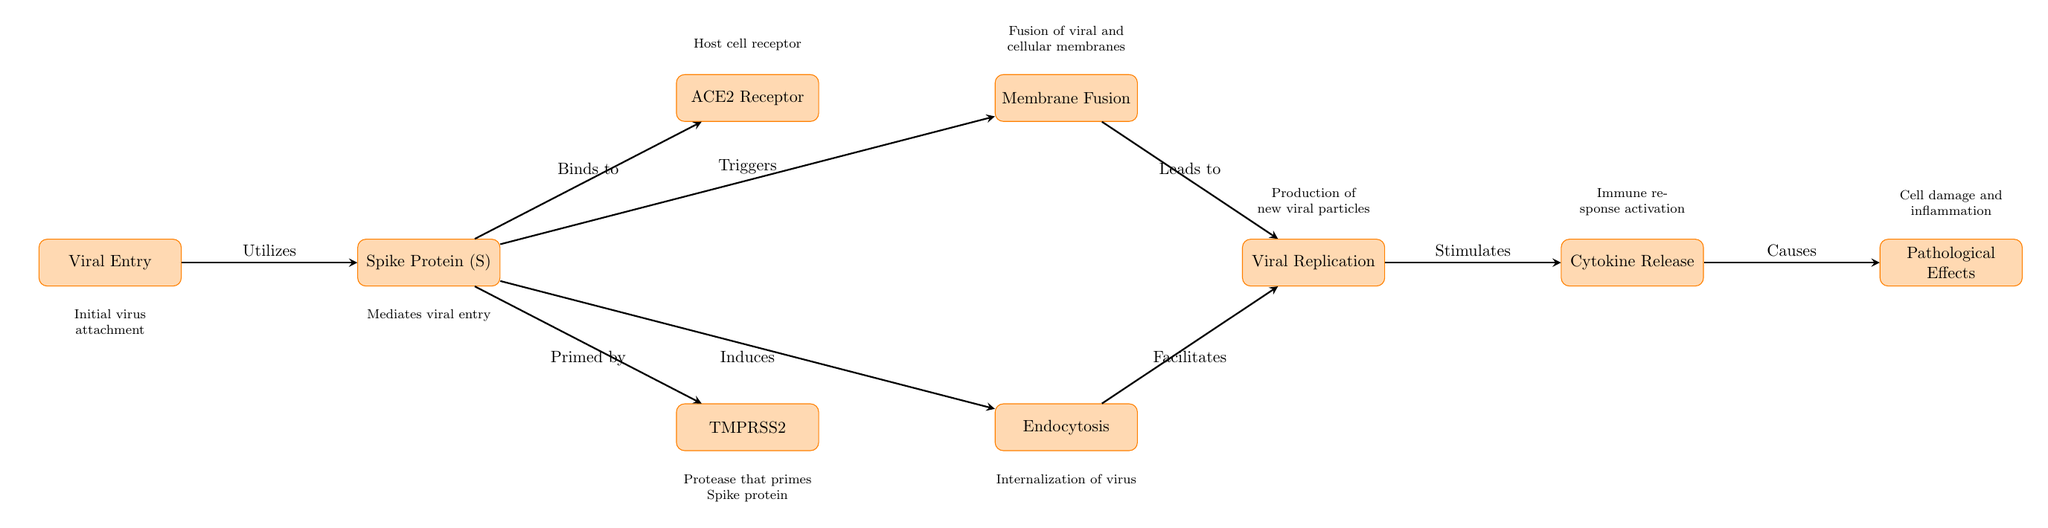What is the first step in the pathogenesis process shown? The diagram indicates that the first step is "Viral Entry," as it is the leftmost node and is connected by the initial arrow from the viral processes.
Answer: Viral Entry How many total processes are listed in the diagram? By counting the number of nodes, there are 8 distinct processes in the diagram from "Viral Entry" to "Pathological Effects."
Answer: 8 What does the Spike Protein bind to? The diagram directly shows an arrow labeled "Binds to" from "Spike Protein (S)" to "ACE2 Receptor," indicating the binding relationship.
Answer: ACE2 Receptor What role does TMPRSS2 play in the process? TMPRSS2 is described within the diagram as a "Protease that primes Spike protein," connecting it to its function in viral entry.
Answer: Priming the Spike protein How do cytokine release and pathological effects relate? The diagram illustrates a direct connection where "Cytokine Release" leads to "Pathological Effects," showing a cause-and-effect relationship.
Answer: Causes What process immediately follows Membrane Fusion? The diagram shows the flow of processes, where "Membrane Fusion" leads into "Viral Replication" as the next step in the pathogenesis.
Answer: Viral Replication How is viral replication stimulated? The diagram indicates that both "Membrane Fusion" and "Endocytosis" are conditions that lead into the process of "Viral Replication," as shown by the arrows connecting these nodes.
Answer: Stimulated by Membrane Fusion and Endocytosis What happens after cytokine release according to the diagram? From the diagram, it is clear that "Cytokine Release" causes "Pathological Effects," establishing a sequential relationship in the process.
Answer: Pathological Effects 